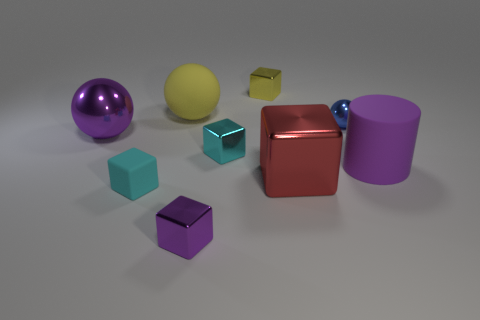Is there any other thing that has the same shape as the purple rubber object?
Your response must be concise. No. There is a large purple metallic thing; is it the same shape as the metallic object that is behind the large yellow matte sphere?
Your answer should be compact. No. There is a ball that is made of the same material as the blue object; what is its color?
Provide a short and direct response. Purple. The large rubber cylinder has what color?
Offer a terse response. Purple. Are the red block and the yellow object in front of the yellow metallic object made of the same material?
Ensure brevity in your answer.  No. How many things are both behind the large purple rubber cylinder and to the left of the yellow shiny block?
Provide a succinct answer. 3. There is a purple matte thing that is the same size as the red shiny block; what is its shape?
Offer a very short reply. Cylinder. There is a purple thing that is behind the cyan thing that is behind the large red metallic thing; are there any yellow cubes to the left of it?
Offer a very short reply. No. There is a large matte cylinder; does it have the same color as the matte thing behind the blue metal object?
Give a very brief answer. No. How many tiny rubber objects are the same color as the large matte cylinder?
Make the answer very short. 0. 